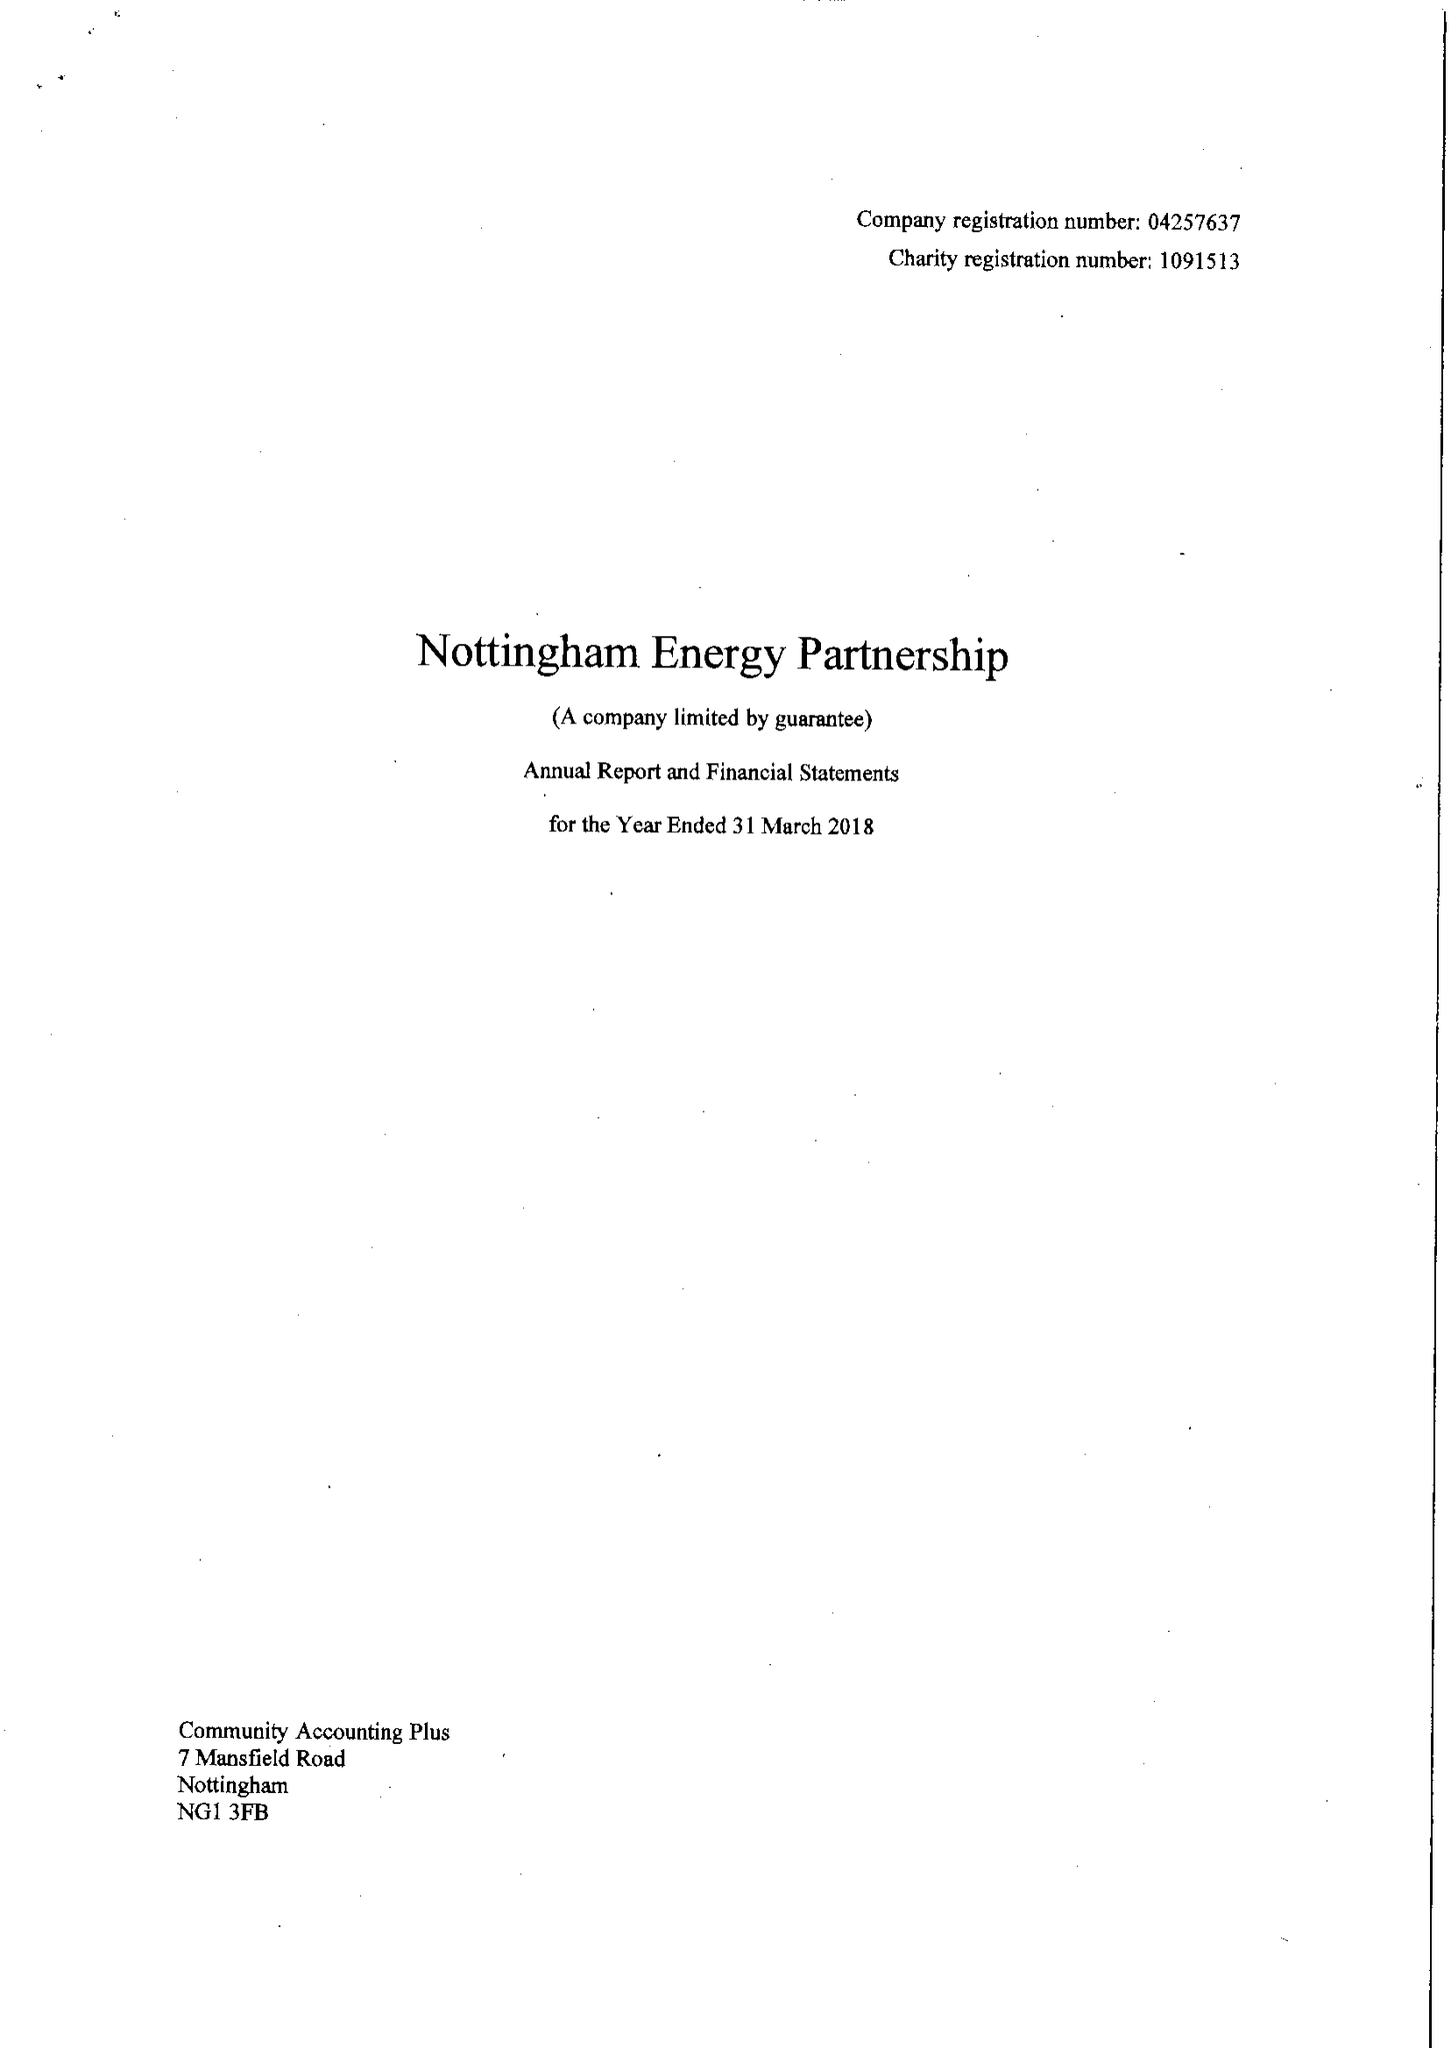What is the value for the address__postcode?
Answer the question using a single word or phrase. NG2 3DY 